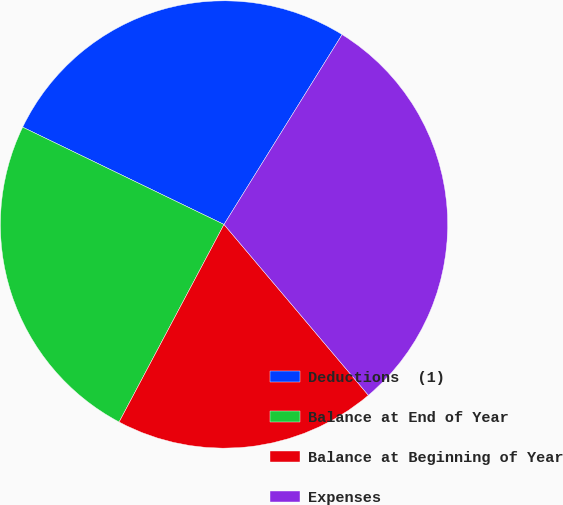<chart> <loc_0><loc_0><loc_500><loc_500><pie_chart><fcel>Deductions  (1)<fcel>Balance at End of Year<fcel>Balance at Beginning of Year<fcel>Expenses<nl><fcel>26.69%<fcel>24.4%<fcel>18.94%<fcel>29.98%<nl></chart> 